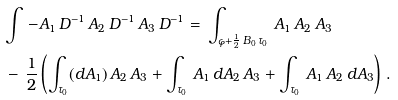Convert formula to latex. <formula><loc_0><loc_0><loc_500><loc_500>& { \int \, - } A _ { 1 } \, D ^ { - 1 } \, A _ { 2 } \, D ^ { - 1 } \, A _ { 3 } \, D ^ { - 1 } = \, \int _ { \varphi + \frac { 1 } { 2 } \, B _ { 0 } \, \tau _ { 0 } } \, A _ { 1 } \, A _ { 2 } \, A _ { 3 } \\ & - \, \frac { 1 } { 2 } \left ( \int _ { \tau _ { 0 } } ( d A _ { 1 } ) \, A _ { 2 } \, A _ { 3 } + \int _ { \tau _ { 0 } } \, A _ { 1 } \, d A _ { 2 } \, A _ { 3 } + \int _ { \tau _ { 0 } } \, A _ { 1 } \, A _ { 2 } \, d A _ { 3 } \right ) \, .</formula> 